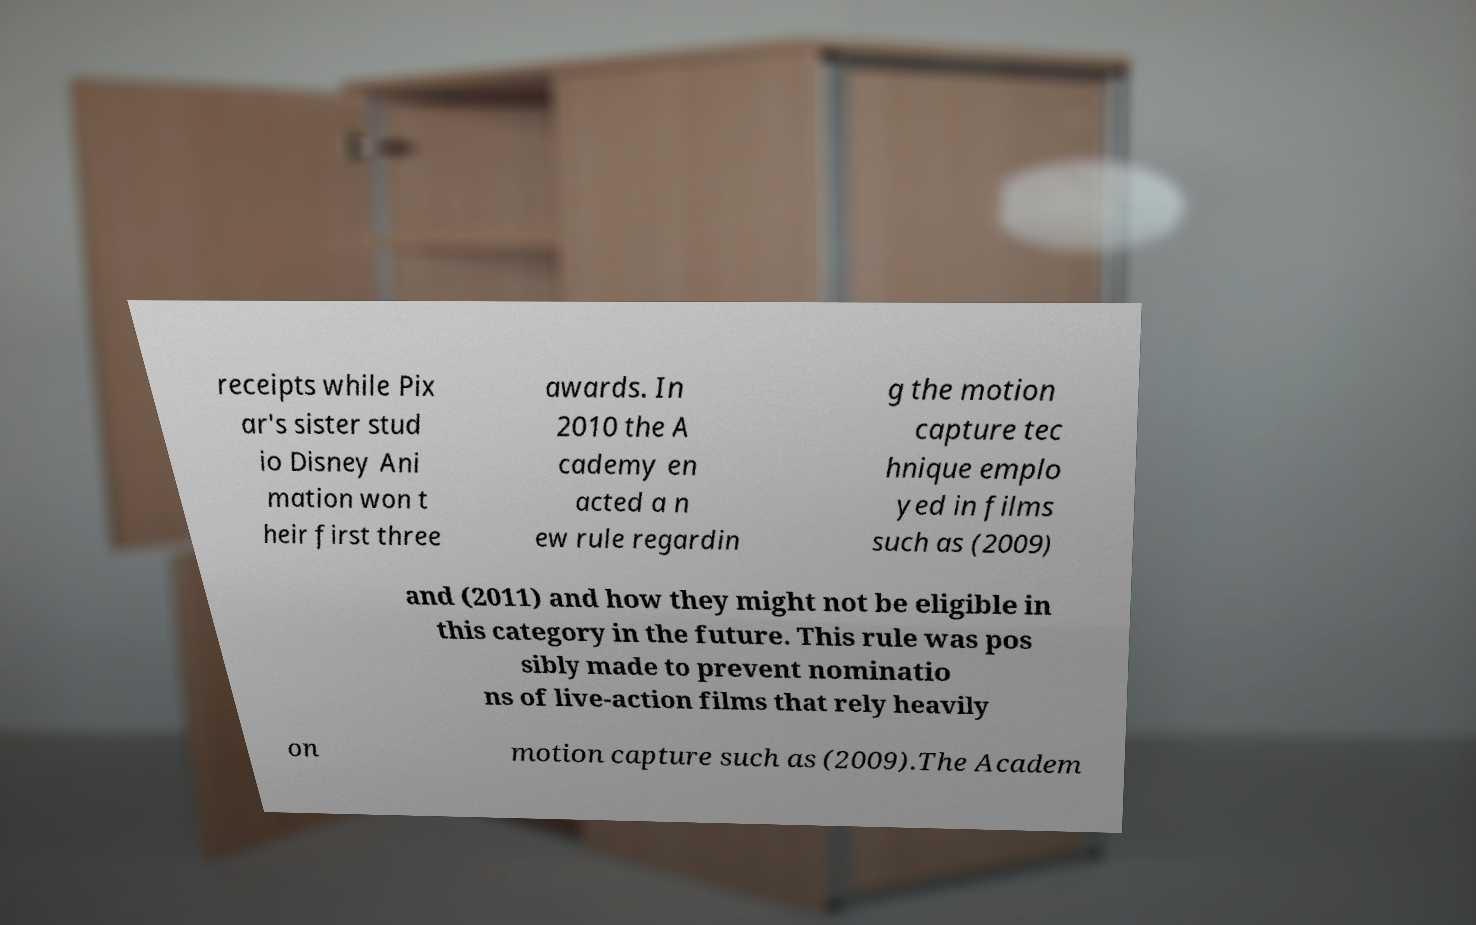Could you assist in decoding the text presented in this image and type it out clearly? receipts while Pix ar's sister stud io Disney Ani mation won t heir first three awards. In 2010 the A cademy en acted a n ew rule regardin g the motion capture tec hnique emplo yed in films such as (2009) and (2011) and how they might not be eligible in this category in the future. This rule was pos sibly made to prevent nominatio ns of live-action films that rely heavily on motion capture such as (2009).The Academ 